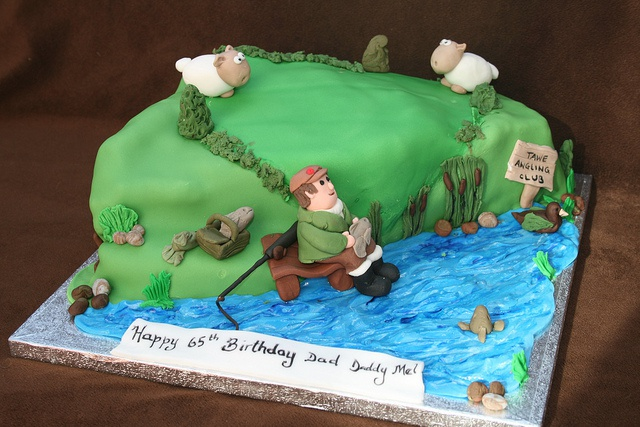Describe the objects in this image and their specific colors. I can see cake in maroon, green, white, lightgreen, and lightblue tones and sheep in maroon, ivory, and tan tones in this image. 